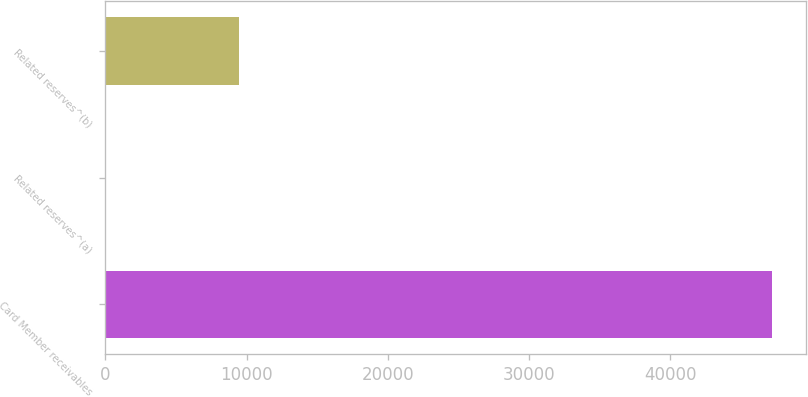<chart> <loc_0><loc_0><loc_500><loc_500><bar_chart><fcel>Card Member receivables<fcel>Related reserves^(a)<fcel>Related reserves^(b)<nl><fcel>47253<fcel>28<fcel>9473<nl></chart> 